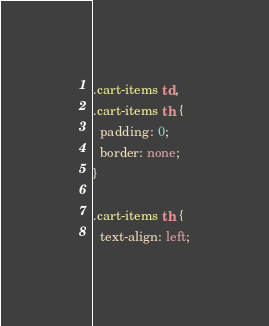Convert code to text. <code><loc_0><loc_0><loc_500><loc_500><_CSS_>.cart-items td,
.cart-items th {
  padding: 0;
  border: none;
}

.cart-items th {
  text-align: left;</code> 